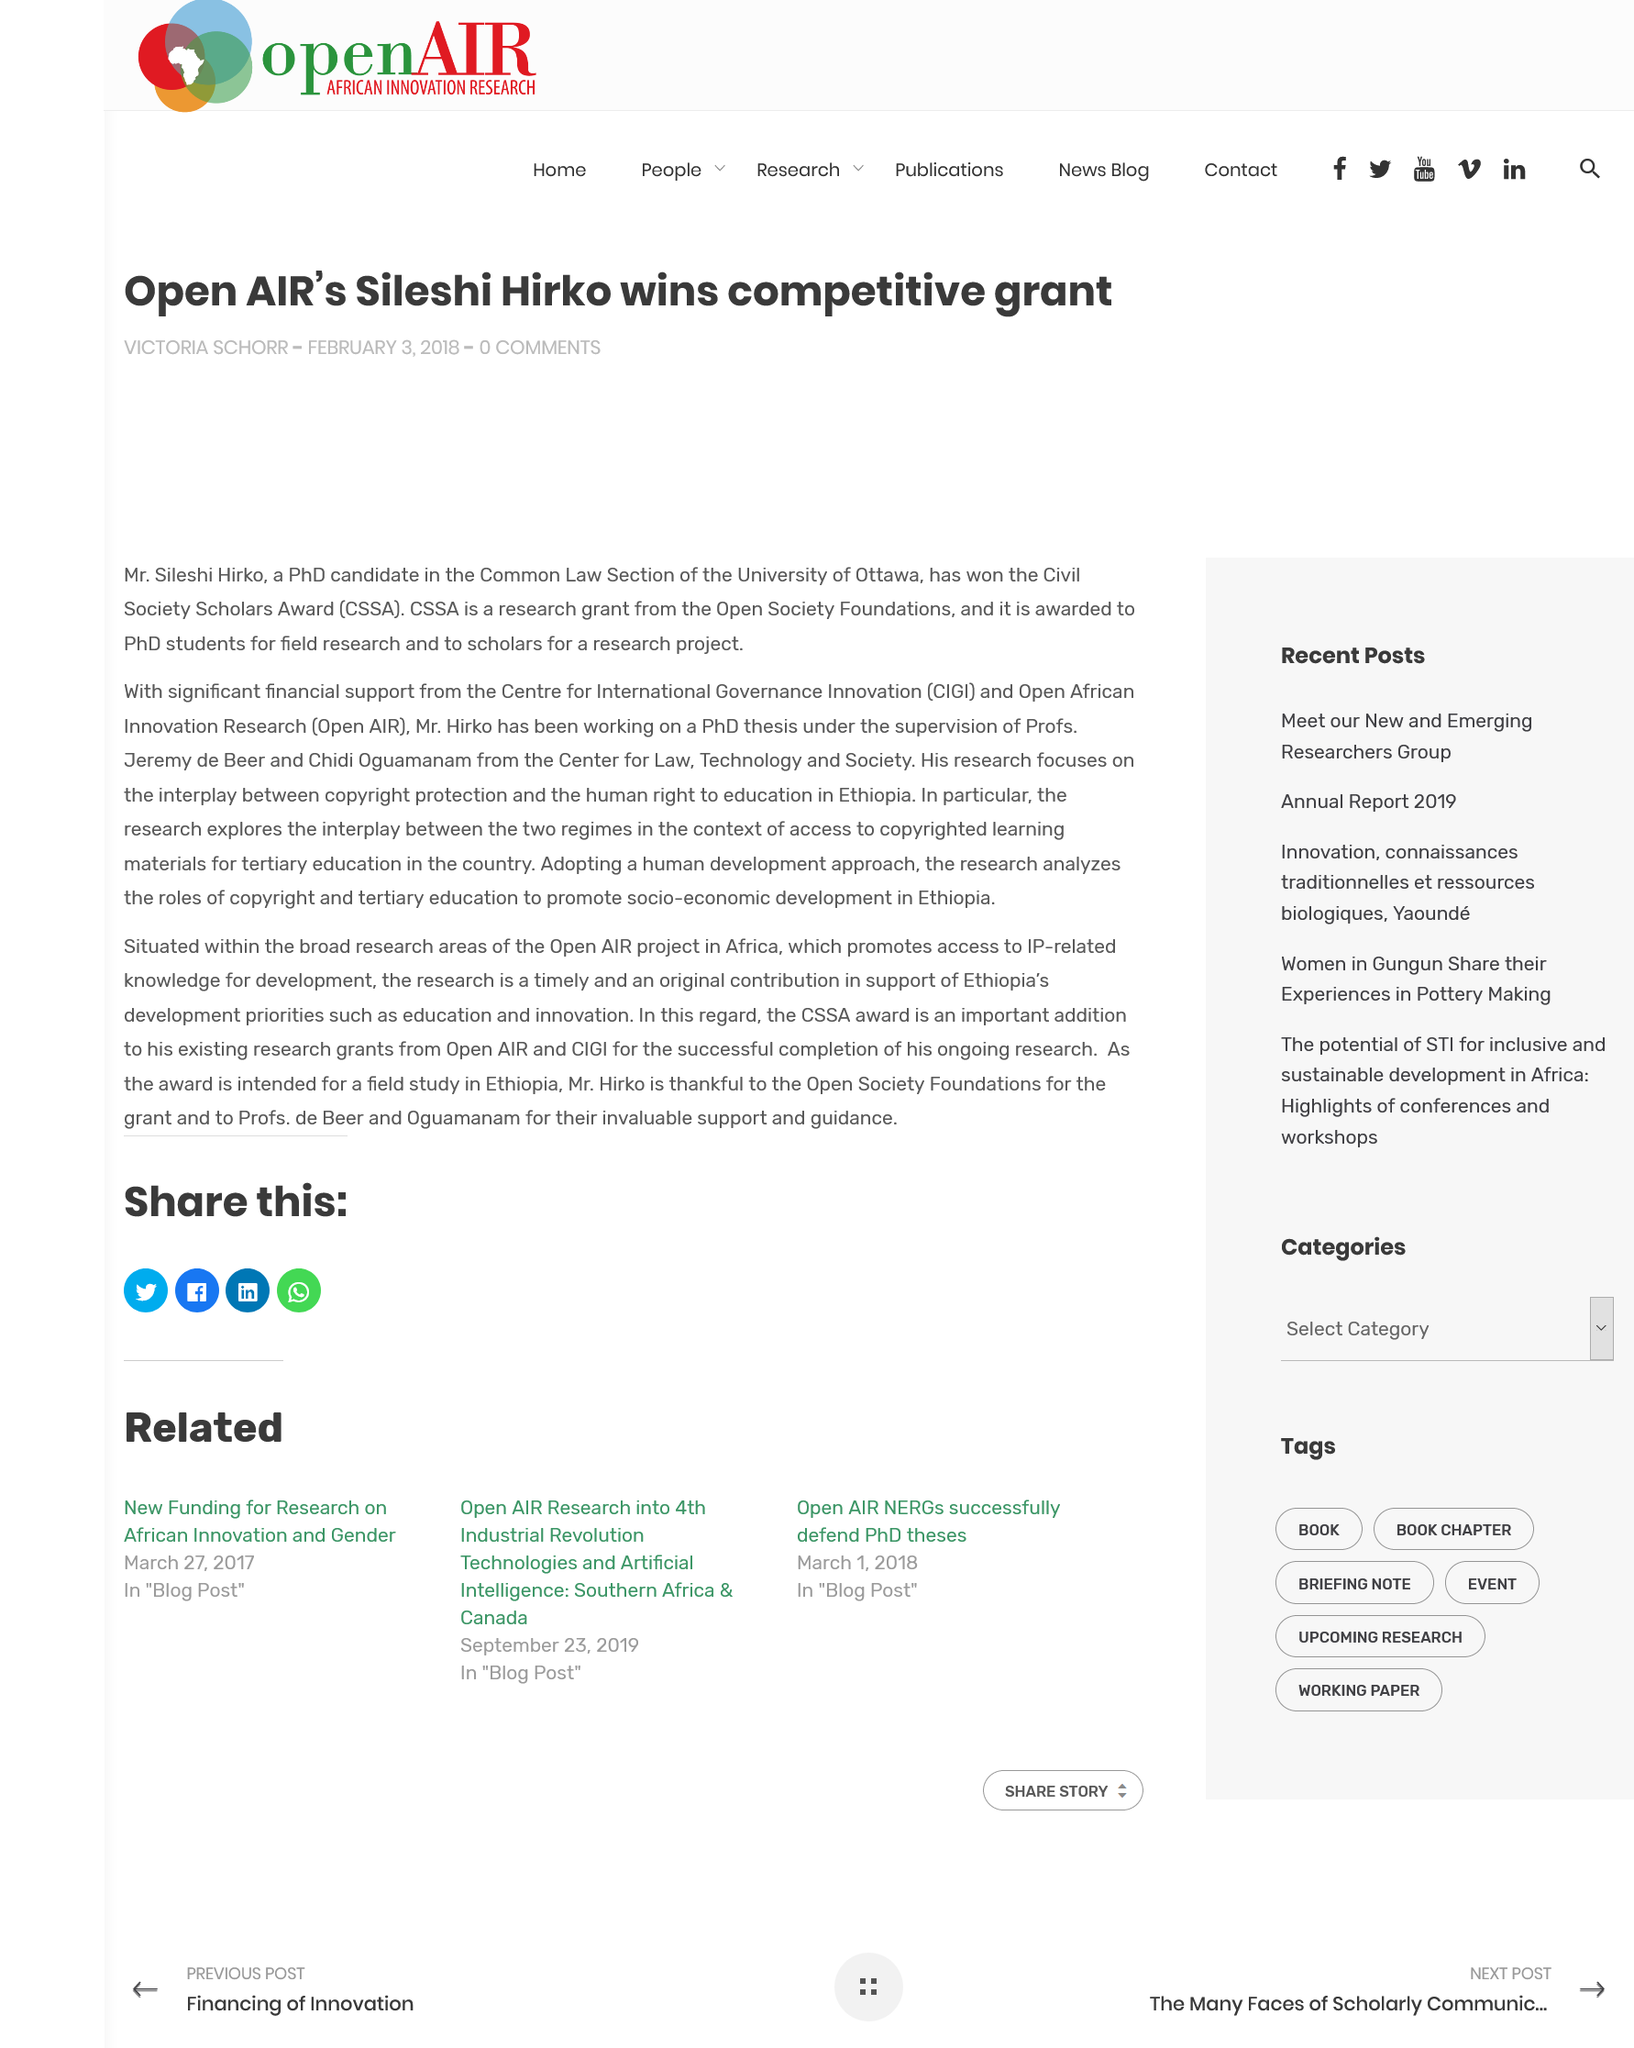Draw attention to some important aspects in this diagram. Hirko's PhD research focuses on the interplay between copyright protection and the human right to education. Sileshi Hirko was the recipient of the Civil Society Scholars Award. The Civil Society Scholars Award is awarded by the Open Society Foundation. 